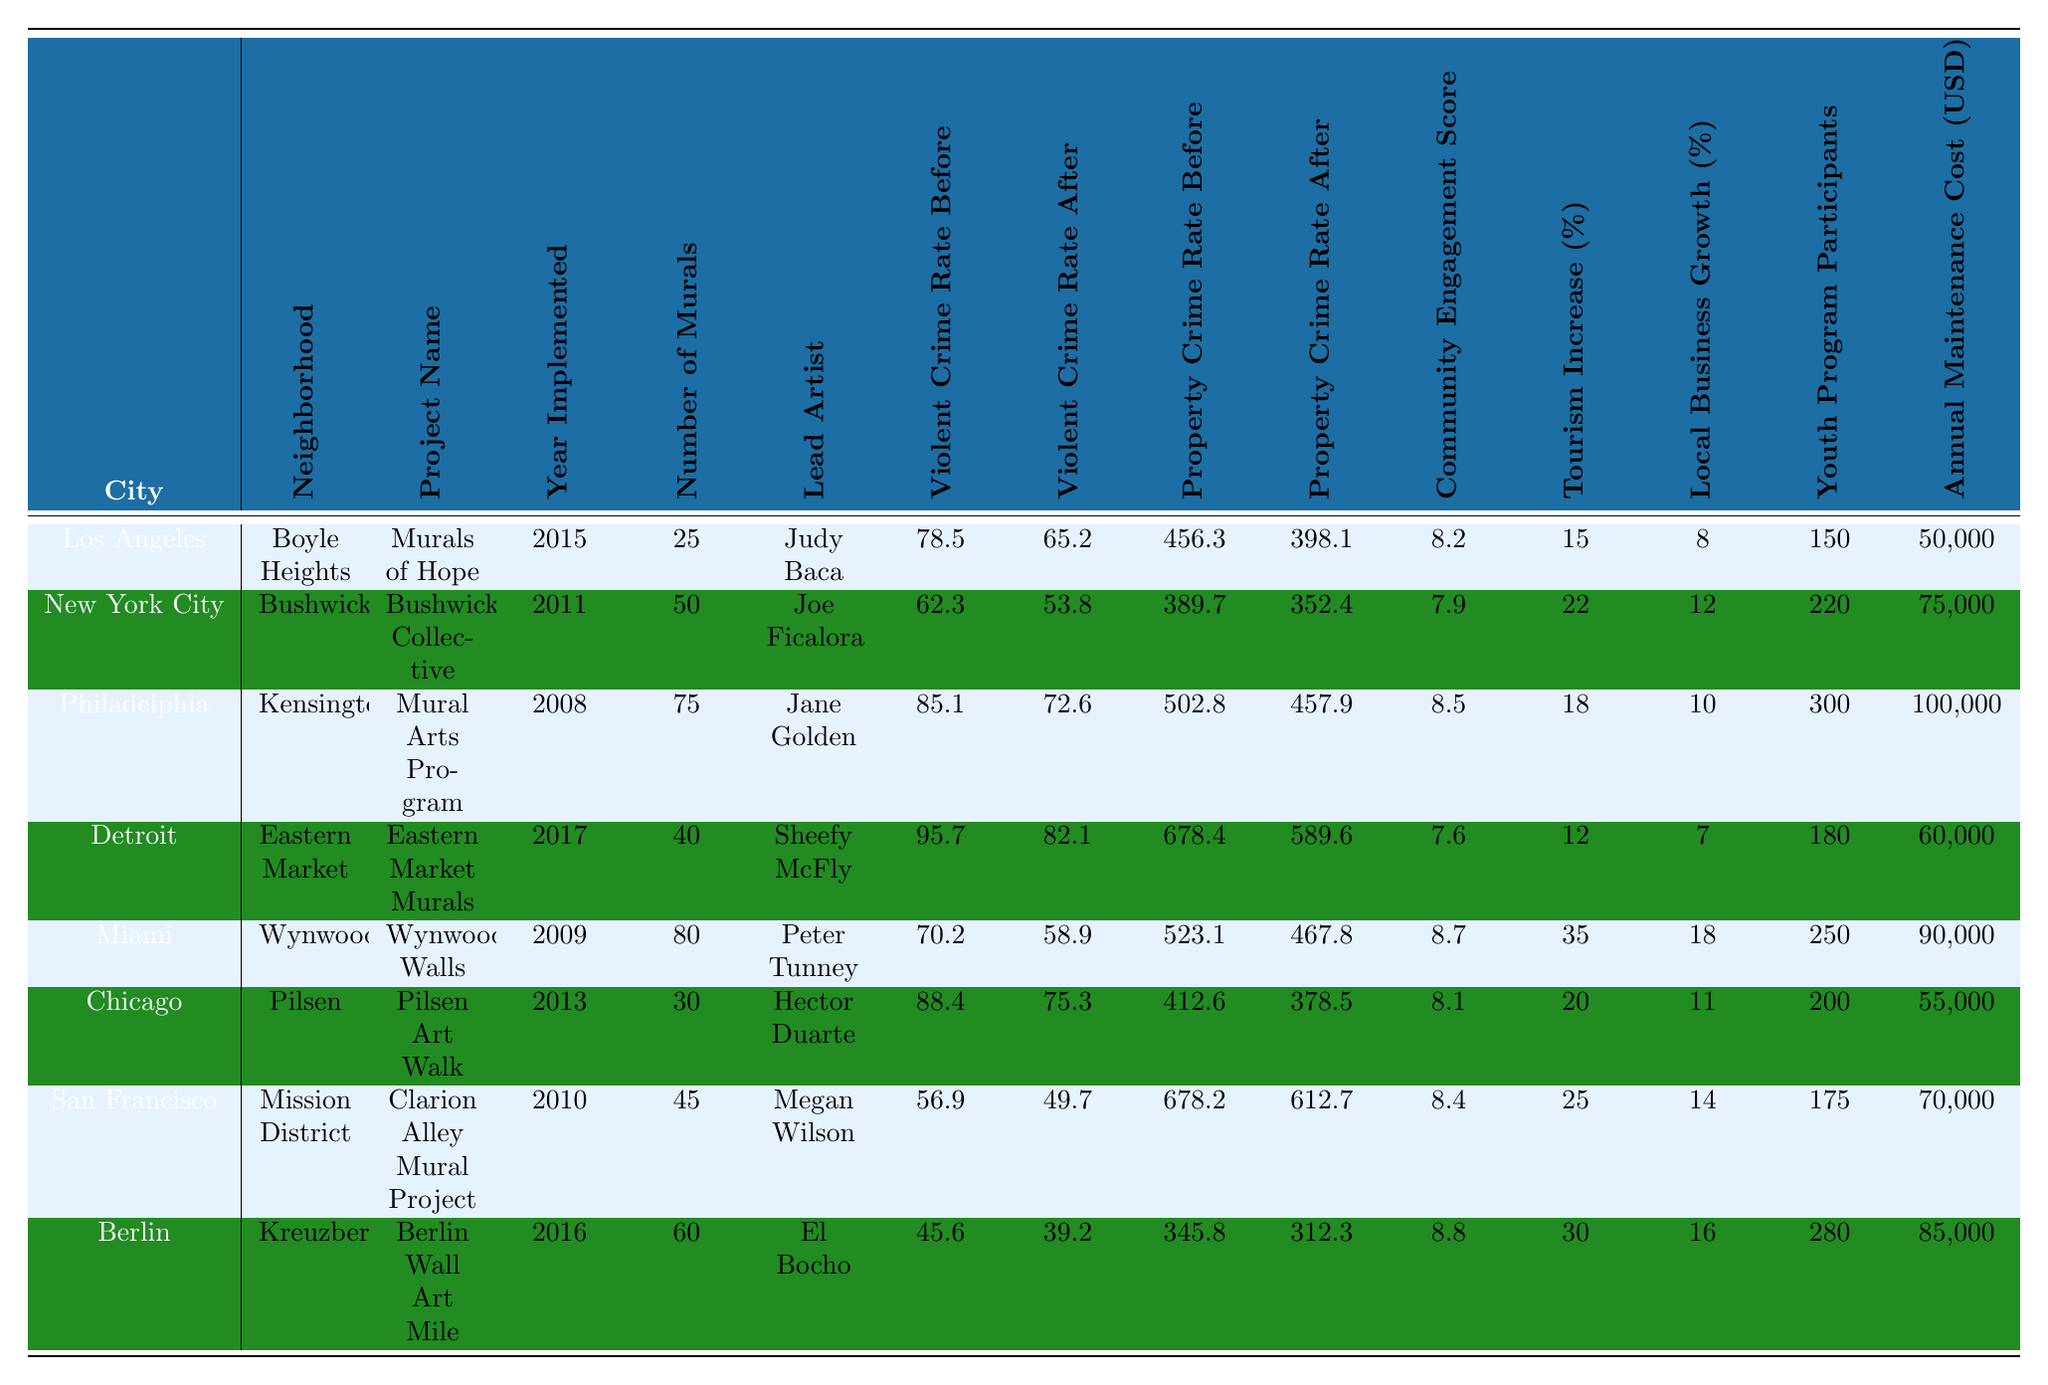What is the community engagement score for Wynwood? Referring to the table, the community engagement score for Wynwood, which is the project "Wynwood Walls," is listed as 8.7.
Answer: 8.7 What was the violent crime rate in Philadelphia before the art project? The table shows that the violent crime rate in Philadelphia before the Mural Arts Program was 85.1.
Answer: 85.1 Which city had the highest number of murals implemented? Upon examining the table, Philadelphia with the Mural Arts Program has the highest number of murals at 75.
Answer: 75 Which project's implementation year was the most recent? Looking at the implementation years, "Eastern Market Murals" in Detroit was implemented in 2017, which is the most recent.
Answer: 2017 What is the difference in the violent crime rate before and after the implementation of the "Bushwick Collective" project? The violent crime rate before was 62.3 and after it decreased to 53.8. The difference is 62.3 - 53.8 = 8.5.
Answer: 8.5 Was there an increase or decrease in property crime rate in Boyle Heights after the art project? The property crime rate before was 456.3 and after it decreased to 398.1, indicating a decrease.
Answer: Decrease How did the tourism increase in Miami compare to that in San Francisco after art projects were implemented? Miami had a tourism increase of 35%, while San Francisco had an increase of 25%. Miami's tourism increase was greater by 10%.
Answer: 10% Was the annual maintenance cost higher for the Kensington murals project than for the Detroit project? The annual maintenance cost for the Kensington project is 100,000, while for Detroit, it is 60,000. Hence, Kensington's cost is higher.
Answer: Yes Which neighborhood experienced the lowest violent crime rate after the project? After the mural projects, Kreuzberg in Berlin had the lowest violent crime rate at 39.2.
Answer: 39.2 What is the average local business growth percentage across all the projects? The local business growth percentages are: 8, 12, 10, 7, 18, 11, 14, and 16. The total is 8 + 12 + 10 + 7 + 18 + 11 + 14 + 16 = 96. Dividing by 8 gives an average of 12%.
Answer: 12% How much did the violent crime rate decrease across all neighborhoods on average? Calculating the average decrease involves adding the individual decreases: (78.5 - 65.2) + (62.3 - 53.8) + (85.1 - 72.6) + (95.7 - 82.1) + (70.2 - 58.9) + (88.4 - 75.3) + (56.9 - 49.7) + (45.6 - 39.2). The total decrease is 13.3 + 8.5 + 12.5 + 13.6 + 11.3 + 13.1 + 7.2 + 6.4 = 45.5. Dividing by 8 gives an average decrease of about 5.69.
Answer: 5.69 